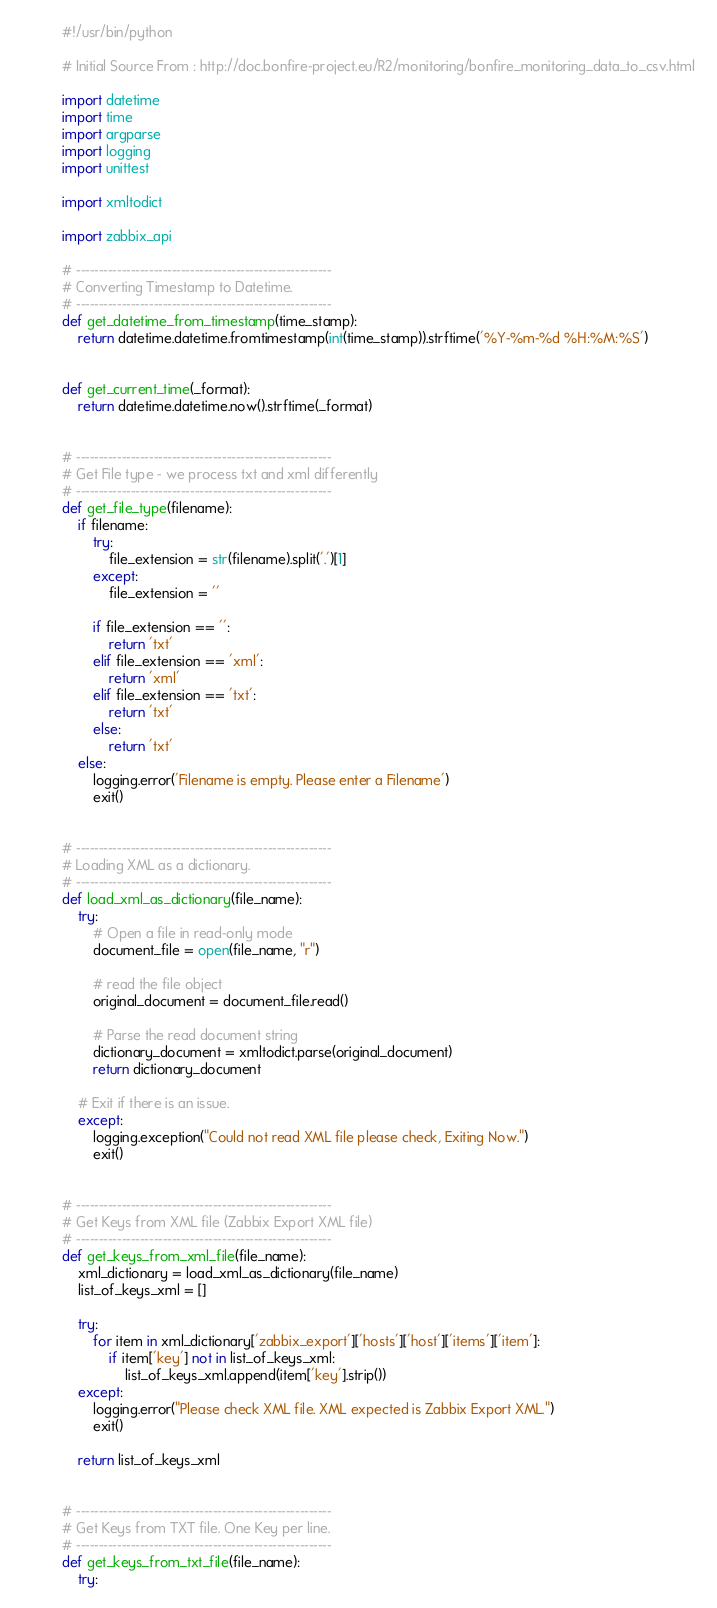<code> <loc_0><loc_0><loc_500><loc_500><_Python_>#!/usr/bin/python

# Initial Source From : http://doc.bonfire-project.eu/R2/monitoring/bonfire_monitoring_data_to_csv.html

import datetime
import time
import argparse
import logging
import unittest

import xmltodict

import zabbix_api

# --------------------------------------------------------
# Converting Timestamp to Datetime.
# --------------------------------------------------------
def get_datetime_from_timestamp(time_stamp):
    return datetime.datetime.fromtimestamp(int(time_stamp)).strftime('%Y-%m-%d %H:%M:%S')


def get_current_time(_format):
    return datetime.datetime.now().strftime(_format)


# --------------------------------------------------------
# Get File type - we process txt and xml differently
# --------------------------------------------------------
def get_file_type(filename):
    if filename:
        try:
            file_extension = str(filename).split('.')[1]
        except:
            file_extension = ''

        if file_extension == '':
            return 'txt'
        elif file_extension == 'xml':
            return 'xml'
        elif file_extension == 'txt':
            return 'txt'
        else:
            return 'txt'
    else:
        logging.error('Filename is empty. Please enter a Filename')
        exit()


# --------------------------------------------------------
# Loading XML as a dictionary.
# --------------------------------------------------------
def load_xml_as_dictionary(file_name):
    try:
        # Open a file in read-only mode
        document_file = open(file_name, "r")

        # read the file object
        original_document = document_file.read()

        # Parse the read document string
        dictionary_document = xmltodict.parse(original_document)
        return dictionary_document

    # Exit if there is an issue.
    except:
        logging.exception("Could not read XML file please check, Exiting Now.")
        exit()


# --------------------------------------------------------
# Get Keys from XML file (Zabbix Export XML file)
# --------------------------------------------------------
def get_keys_from_xml_file(file_name):
    xml_dictionary = load_xml_as_dictionary(file_name)
    list_of_keys_xml = []

    try:
        for item in xml_dictionary['zabbix_export']['hosts']['host']['items']['item']:
            if item['key'] not in list_of_keys_xml:
                list_of_keys_xml.append(item['key'].strip())
    except:
        logging.error("Please check XML file. XML expected is Zabbix Export XML.")
        exit()

    return list_of_keys_xml


# --------------------------------------------------------
# Get Keys from TXT file. One Key per line.
# --------------------------------------------------------
def get_keys_from_txt_file(file_name):
    try:</code> 